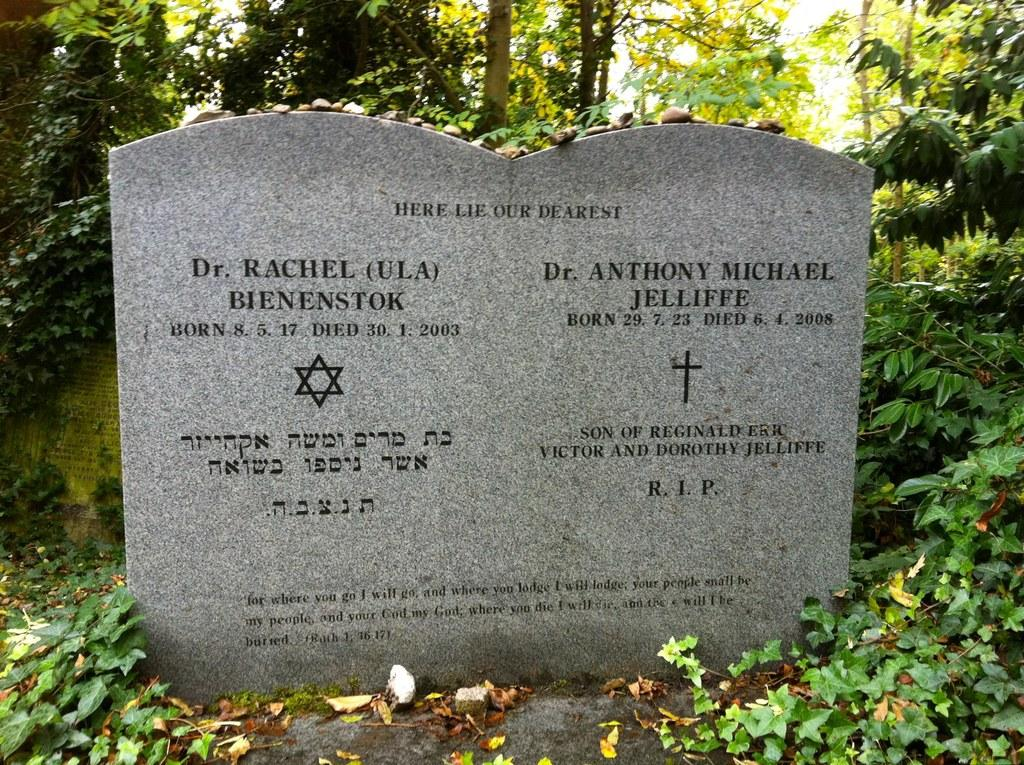What is the main object in the image? There is a stone sheet in the image. What is written or depicted on the stone sheet? There is text and symbols on the stone sheet. What type of natural elements can be seen in the image? Leaves, grass, trees, and the sky are visible in the image. How many planes are flying in the image? There are no planes visible in the image. What color is the sock on the tree in the image? There is no sock present in the image. 